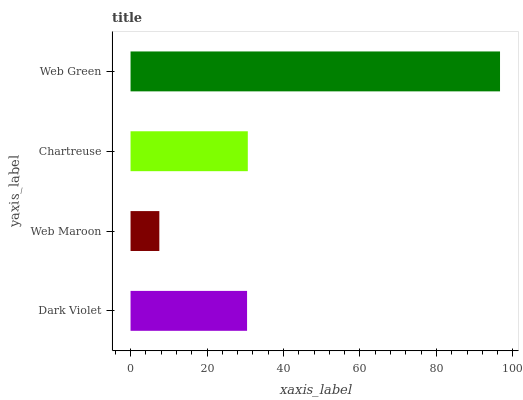Is Web Maroon the minimum?
Answer yes or no. Yes. Is Web Green the maximum?
Answer yes or no. Yes. Is Chartreuse the minimum?
Answer yes or no. No. Is Chartreuse the maximum?
Answer yes or no. No. Is Chartreuse greater than Web Maroon?
Answer yes or no. Yes. Is Web Maroon less than Chartreuse?
Answer yes or no. Yes. Is Web Maroon greater than Chartreuse?
Answer yes or no. No. Is Chartreuse less than Web Maroon?
Answer yes or no. No. Is Chartreuse the high median?
Answer yes or no. Yes. Is Dark Violet the low median?
Answer yes or no. Yes. Is Dark Violet the high median?
Answer yes or no. No. Is Web Green the low median?
Answer yes or no. No. 